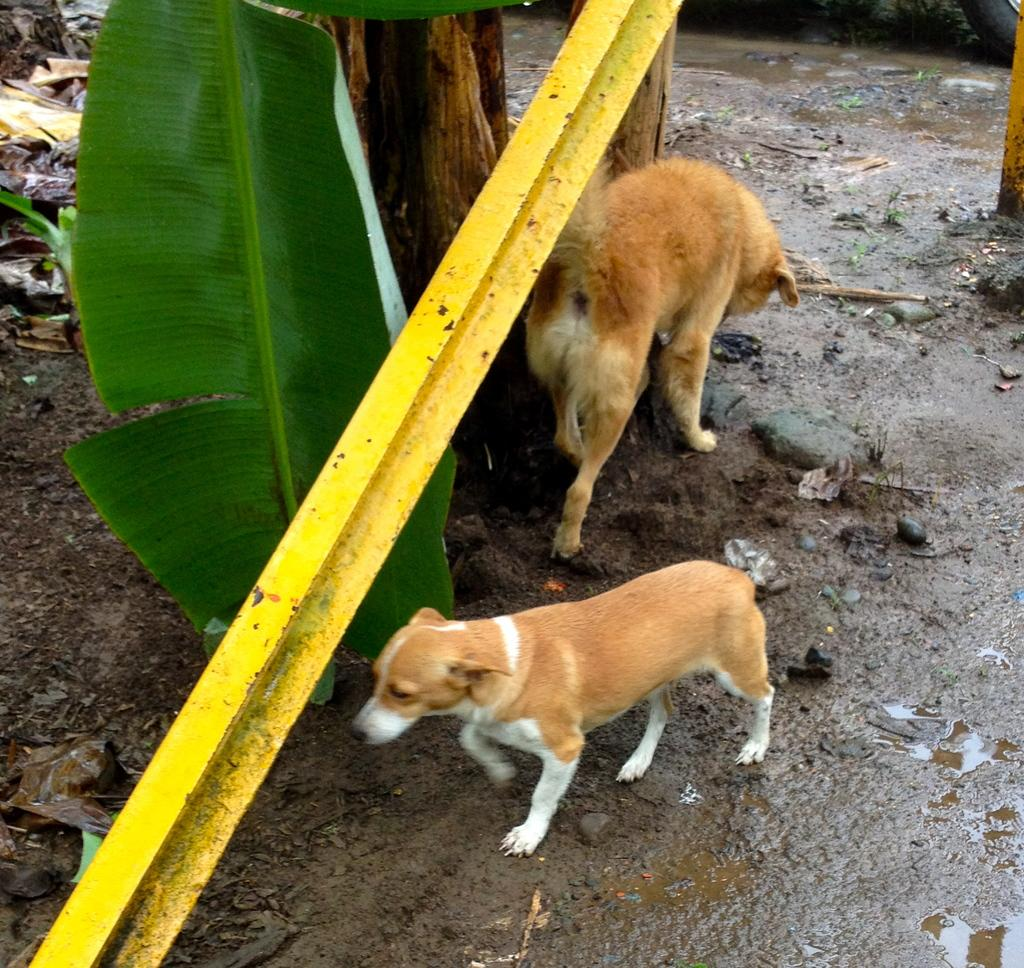How many dogs are present in the image? There are two dogs in the image. What is the color of the rod in the image? The rod in the image is yellow. What type of plant material can be seen in the image? There is a leaf in the image. What type of apparel are the dogs wearing in the image? There is no mention of apparel or clothing on the dogs in the image. How many clouds can be seen in the image? There is no mention of clouds in the image; it only includes two dogs, a yellow rod, and a leaf. 